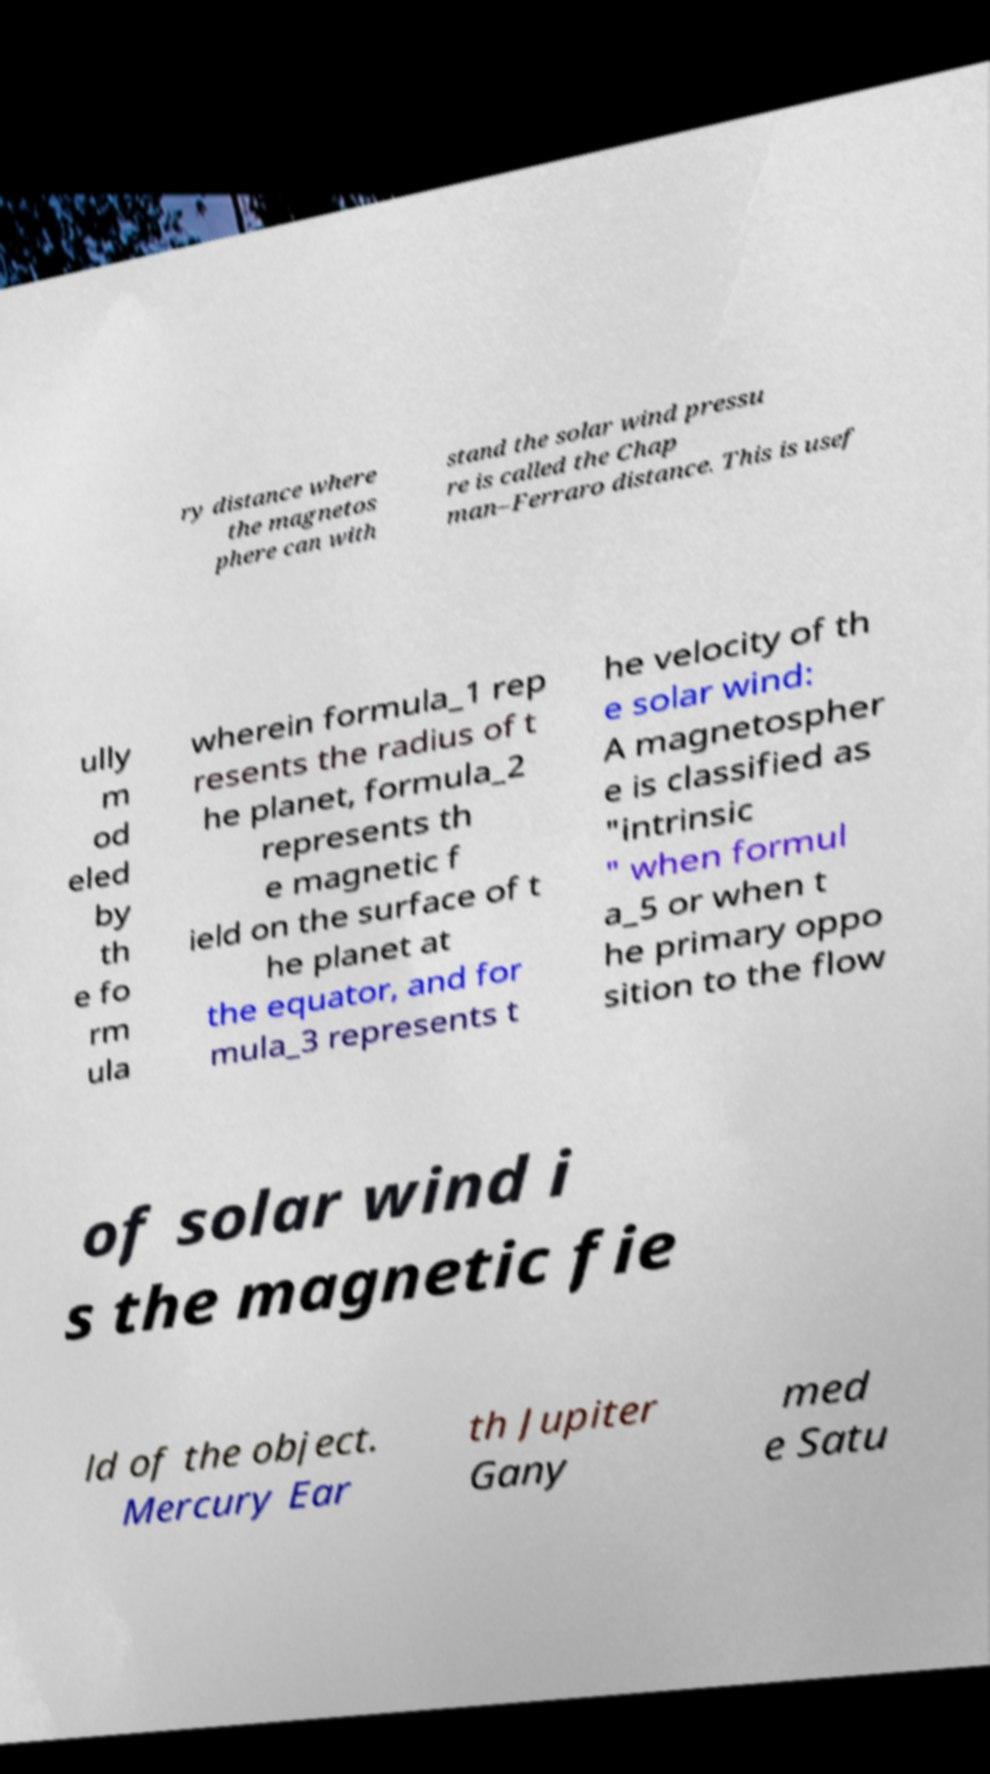What messages or text are displayed in this image? I need them in a readable, typed format. ry distance where the magnetos phere can with stand the solar wind pressu re is called the Chap man–Ferraro distance. This is usef ully m od eled by th e fo rm ula wherein formula_1 rep resents the radius of t he planet, formula_2 represents th e magnetic f ield on the surface of t he planet at the equator, and for mula_3 represents t he velocity of th e solar wind: A magnetospher e is classified as "intrinsic " when formul a_5 or when t he primary oppo sition to the flow of solar wind i s the magnetic fie ld of the object. Mercury Ear th Jupiter Gany med e Satu 